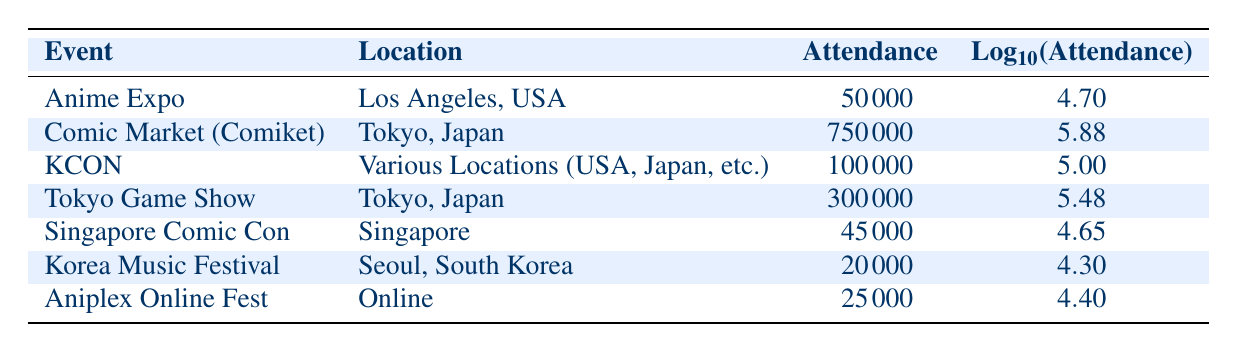What is the attendance for Comic Market (Comiket)? The table clearly lists the attendance for Comic Market (Comiket) as one of the events. Referring to the row for Comic Market, the attendance is directly given as 750000.
Answer: 750000 Which event has the highest attendance? By examining the attendance values in the table, we see that Comic Market (Comiket) has the highest attendance listed at 750000. Therefore, it is the event with the highest attendance.
Answer: Comic Market (Comiket) What is the average attendance of all the events listed in the table? To find the average attendance, we first sum all the attendance values: 50000 + 750000 + 100000 + 300000 + 45000 + 20000 + 25000 = 1225000. There are 7 events, so we divide the total attendance by the number of events: 1225000 / 7 ≈ 175000.
Answer: 175000 Is the attendance for the Korea Music Festival less than 30000? The attendance for the Korea Music Festival is listed as 20000. Since 20000 is less than 30000, the answer is true.
Answer: Yes Which event has an attendance value that is more than 100000 but less than 500000? The attendance values in the table show that Tokyo Game Show has an attendance of 300000 and KCON has an attendance of exactly 100000. It meets the criteria of being more than 100000. Thus, the event that fits the criteria is Tokyo Game Show.
Answer: Tokyo Game Show What is the attendance for events held in Tokyo? In reviewing the table, we see two events held in Tokyo: Comic Market (Comiket) with 750000 attendees and Tokyo Game Show with 300000 attendees. Summing these gives us 750000 + 300000 = 1050000 for the total attendance of events held in Tokyo.
Answer: 1050000 Does Singapore Comic Con have the highest attendance among the events listed? Referring to the attendance figures in the table, Singapore Comic Con has an attendance of 45000, which is lower than other events such as Comic Market (Comiket) and Tokyo Game Show. Thus, it does not have the highest attendance.
Answer: No What is the difference in attendance between the Anime Expo and Korea Music Festival? The attendance for Anime Expo is 50000 and for Korea Music Festival is 20000. To find the difference, we subtract Korea Music Festival's attendance from Anime Expo's: 50000 - 20000 = 30000.
Answer: 30000 